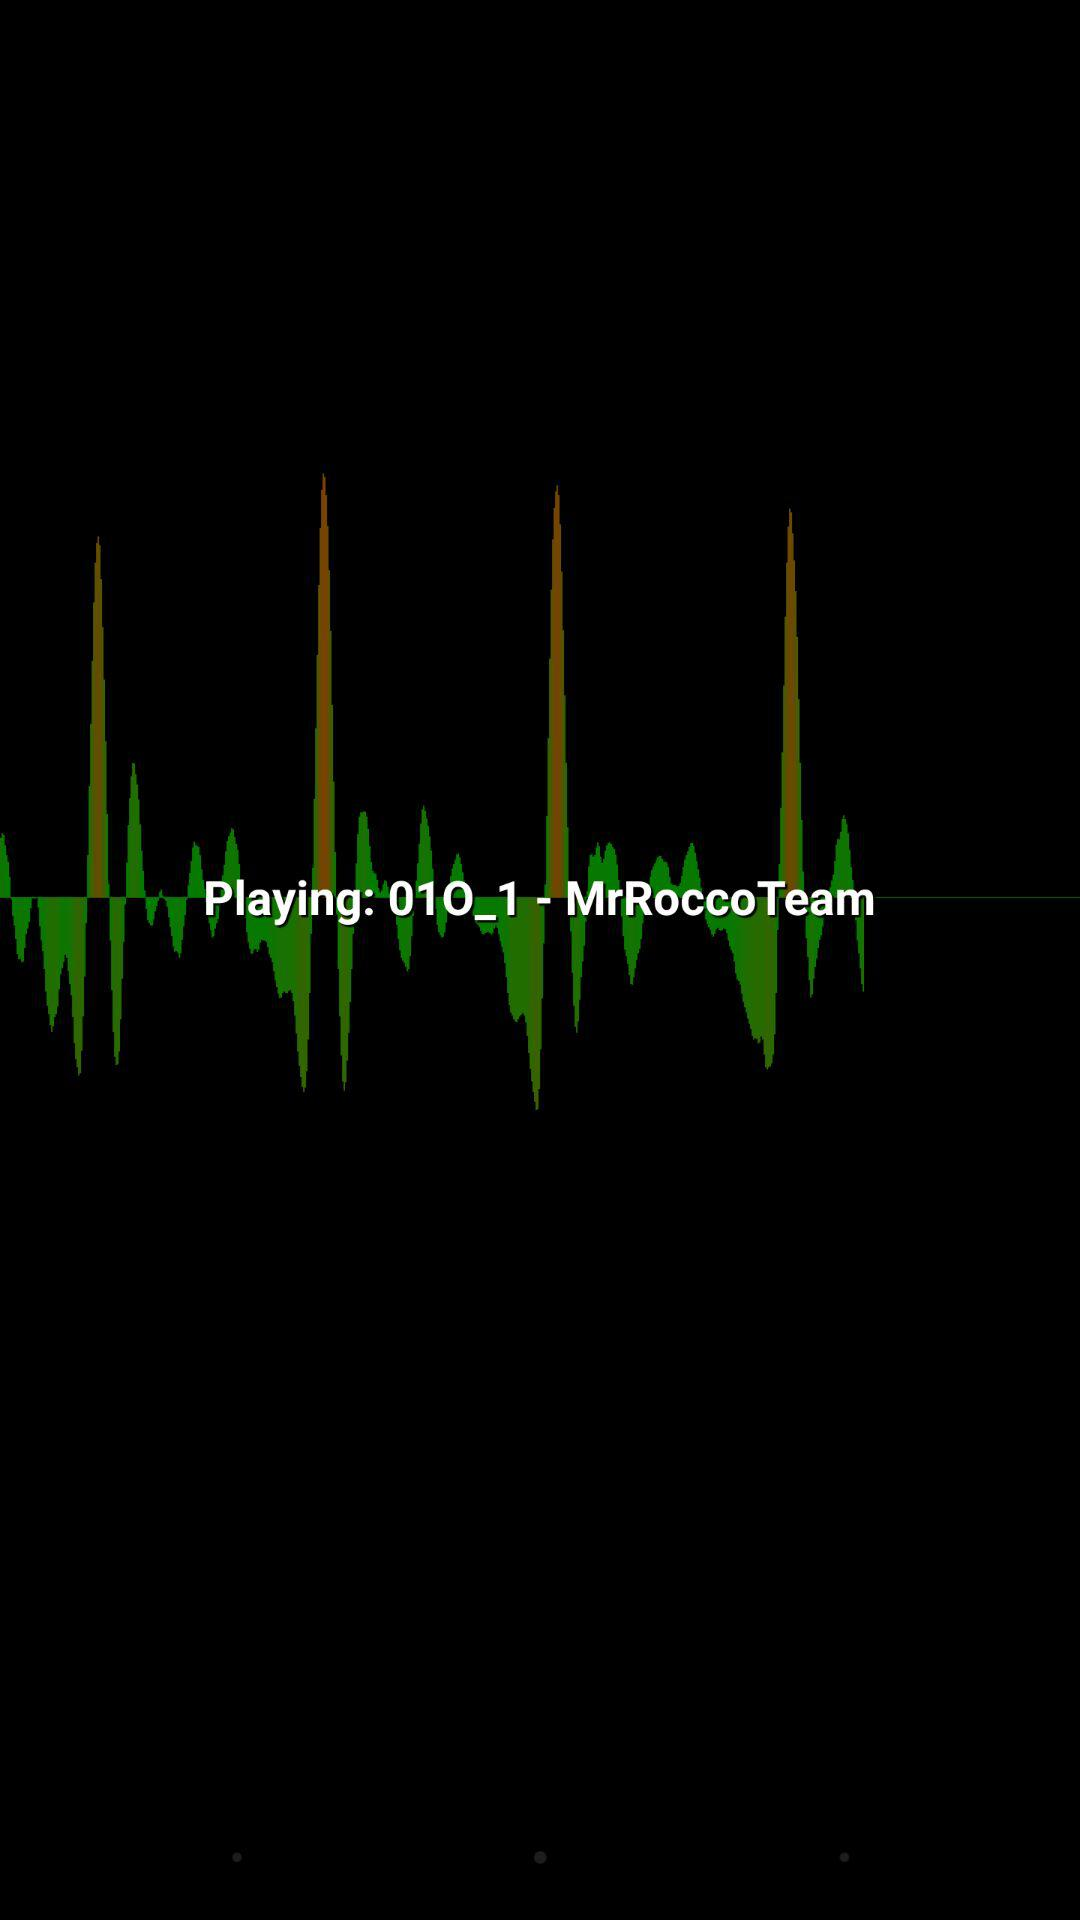What audio is currently playing? The audio "01O_1 - MrRoccoTeam" is currently playing. 